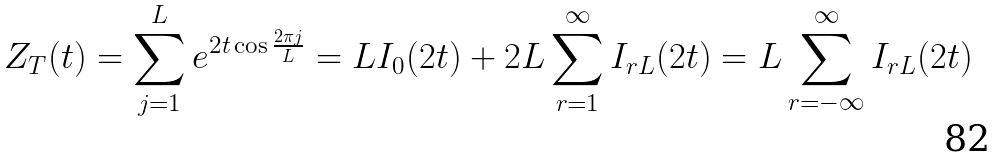Convert formula to latex. <formula><loc_0><loc_0><loc_500><loc_500>Z _ { T } ( t ) = \sum _ { j = 1 } ^ { L } e ^ { 2 t \cos \frac { 2 \pi j } { L } } = L I _ { 0 } ( 2 t ) + 2 L \sum _ { r = 1 } ^ { \infty } I _ { r L } ( 2 t ) = L \sum _ { r = - \infty } ^ { \infty } I _ { r L } ( 2 t )</formula> 